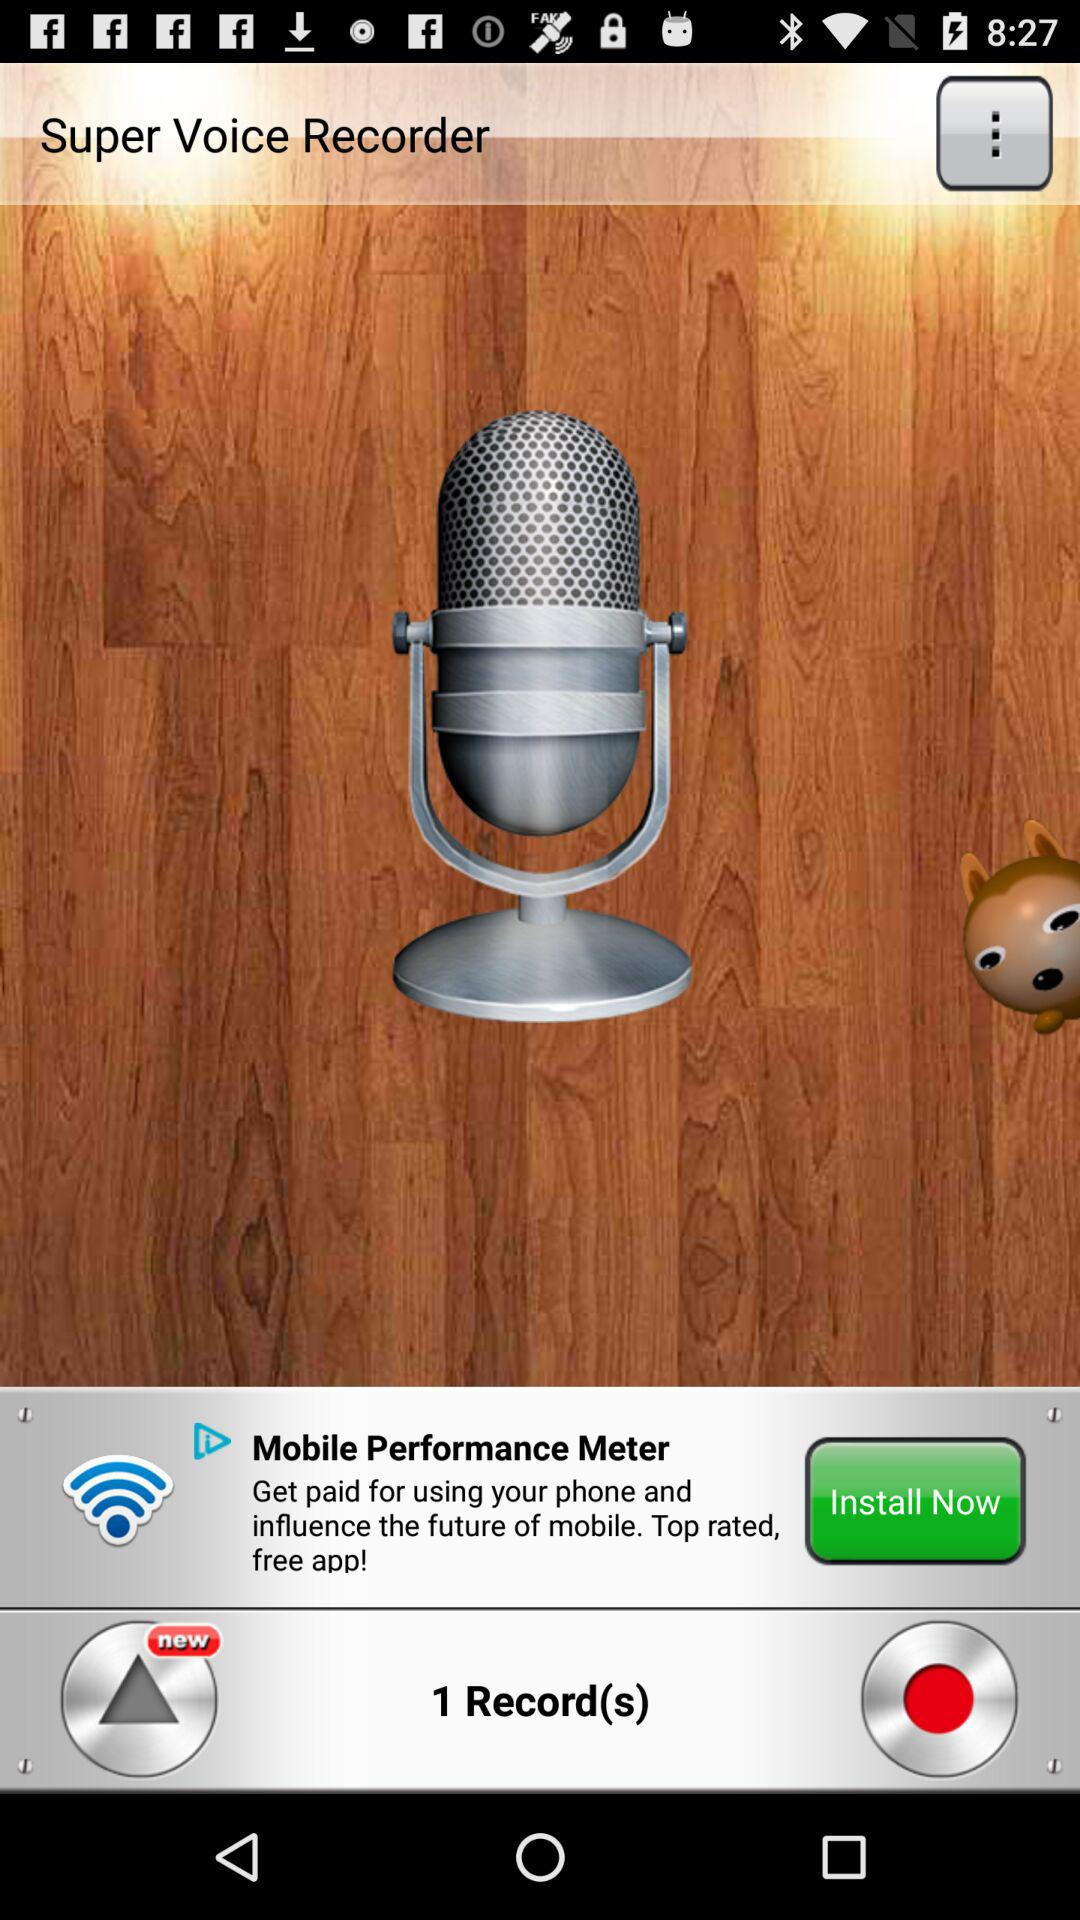What is the application name? The application name is "Super Voice Recorder". 